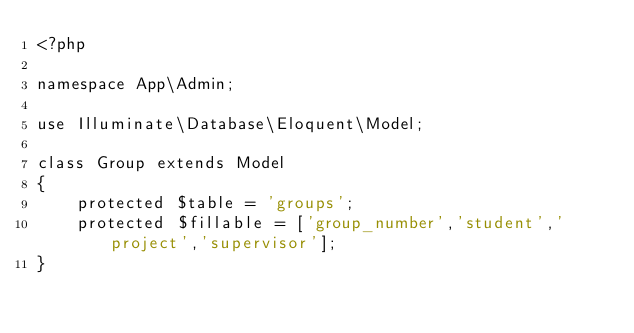<code> <loc_0><loc_0><loc_500><loc_500><_PHP_><?php

namespace App\Admin;

use Illuminate\Database\Eloquent\Model;

class Group extends Model
{
    protected $table = 'groups';
    protected $fillable = ['group_number','student','project','supervisor'];
}
</code> 